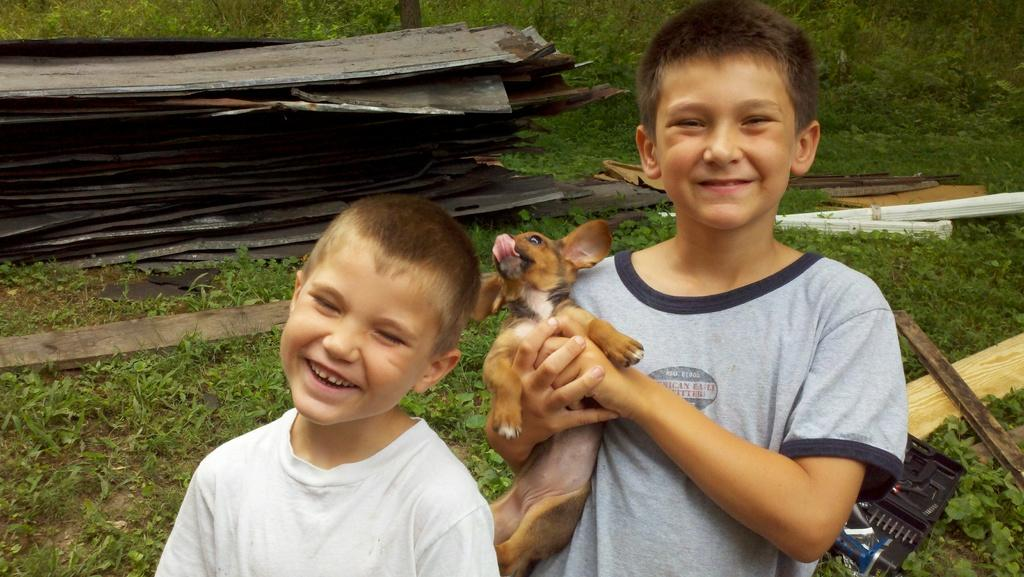What are the children in the image doing? The two children are standing and smiling in the image. What is the boy holding in his hands? The boy is holding a dog in his hands. What type of surface is visible in the image? There is grass visible in the image. What type of canvas is the boy using to paint in the image? There is no canvas or painting activity present in the image. What is the cook preparing in the background of the image? There is no cook or food preparation visible in the image. 